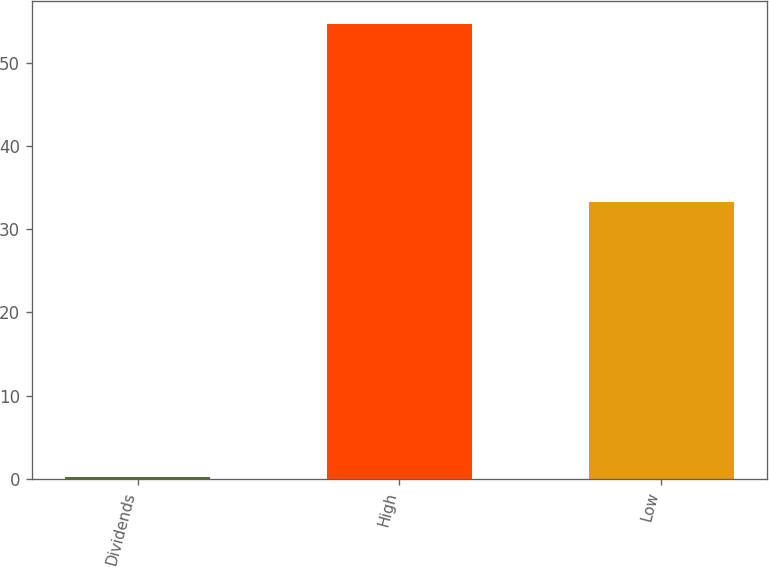<chart> <loc_0><loc_0><loc_500><loc_500><bar_chart><fcel>Dividends<fcel>High<fcel>Low<nl><fcel>0.27<fcel>54.66<fcel>33.28<nl></chart> 